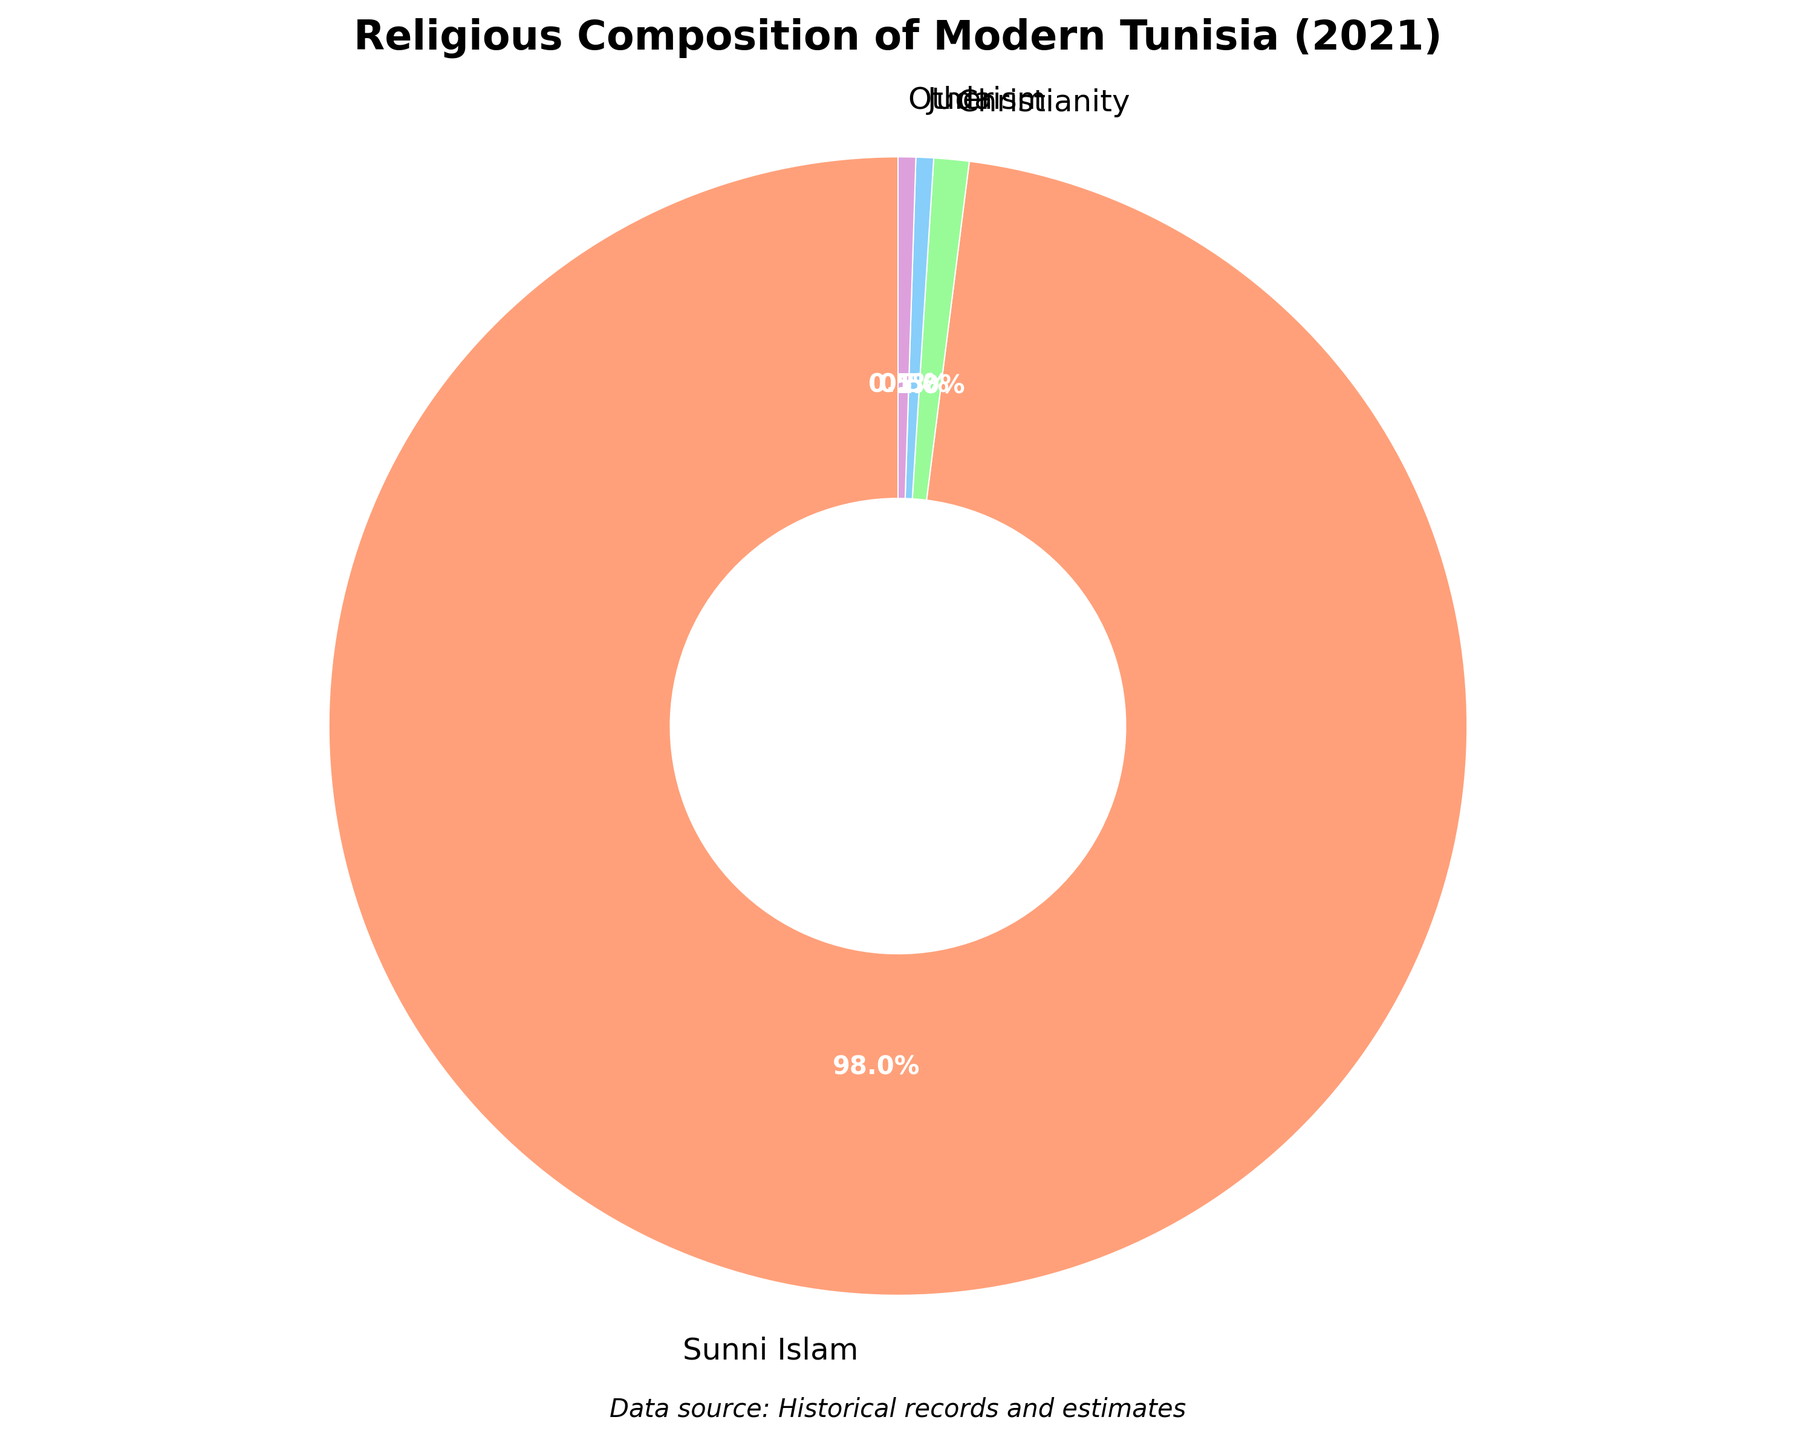Who represents 98% of the religious composition in Modern Tunisia? By looking at the pie chart, the section with the largest percentage, 98%, is labeled "Sunni Islam."
Answer: Sunni Islam What is the difference in percentage between Christianity and Judaism in Modern Tunisia? The percentage of Christianity is 1%, and the percentage of Judaism is 0.5%. The difference is calculated as 1% - 0.5% = 0.5%.
Answer: 0.5% Which religion has the smallest percentage in Modern Tunisia? Sectors with the smallest percentages often look the smallest visually. In this chart, "Judaism" and "Other" both have the smallest sizes and are listed as having 0.5%.
Answer: Judaism, Other How much higher is the percentage of Sunni Islam compared to all other religions combined in Modern Tunisia? The percentage of Sunni Islam is 98%. The rest combine to (1% + 0.5% + 0.5%) = 2%. The difference is 98% - 2% = 96%.
Answer: 96% Which section of the pie chart is second largest in Modern Tunisia? By observing the sizes, "Christianity" at 1% is the second largest section after "Sunni Islam."
Answer: Christianity What's the average percentage for Christianity and Judaism in Modern Tunisia? Christianity is 1% and Judaism is 0.5%. Adding them gives 1.5%, and averaging by 2 is 1.5% / 2 = 0.75%.
Answer: 0.75% How does the proportion of "Other" compare to "Christianity" in Modern Tunisia? Both "Other" and "Christianity" have labels showing small percentages, with "Christianity" being 1% and "Other" being 0.5%. Therefore, the proportion of "Christianity" is twice that of "Other."
Answer: Christianity is twice "Other" In which visual segment would you find the representation of Judaism? Each section of the pie chart is visually distinct, with Judaism represented by one of the smallest segments, labeled at 0.5%.
Answer: Smallest segment What religions are represented by a blue segment in the pie chart? Visually identifying the colors, the blue segment in the chart corresponds to "Judaism," representing 0.5%.
Answer: Judaism 